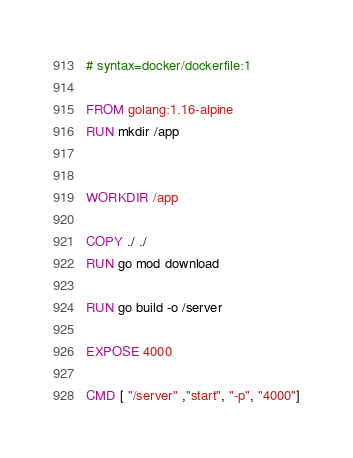<code> <loc_0><loc_0><loc_500><loc_500><_Dockerfile_># syntax=docker/dockerfile:1

FROM golang:1.16-alpine
RUN mkdir /app


WORKDIR /app

COPY ./ ./
RUN go mod download

RUN go build -o /server

EXPOSE 4000

CMD [ "/server" ,"start", "-p", "4000"]</code> 